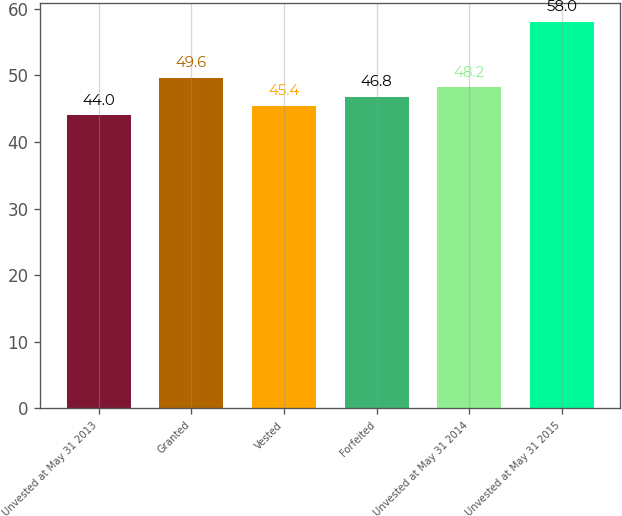<chart> <loc_0><loc_0><loc_500><loc_500><bar_chart><fcel>Unvested at May 31 2013<fcel>Granted<fcel>Vested<fcel>Forfeited<fcel>Unvested at May 31 2014<fcel>Unvested at May 31 2015<nl><fcel>44<fcel>49.6<fcel>45.4<fcel>46.8<fcel>48.2<fcel>58<nl></chart> 